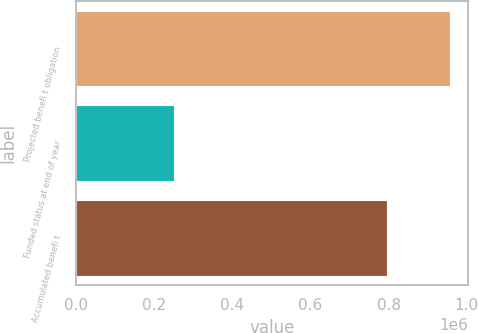<chart> <loc_0><loc_0><loc_500><loc_500><bar_chart><fcel>Projected benefi t obligation<fcel>Funded status at end of year<fcel>Accumulated benefi t<nl><fcel>956172<fcel>251196<fcel>796000<nl></chart> 